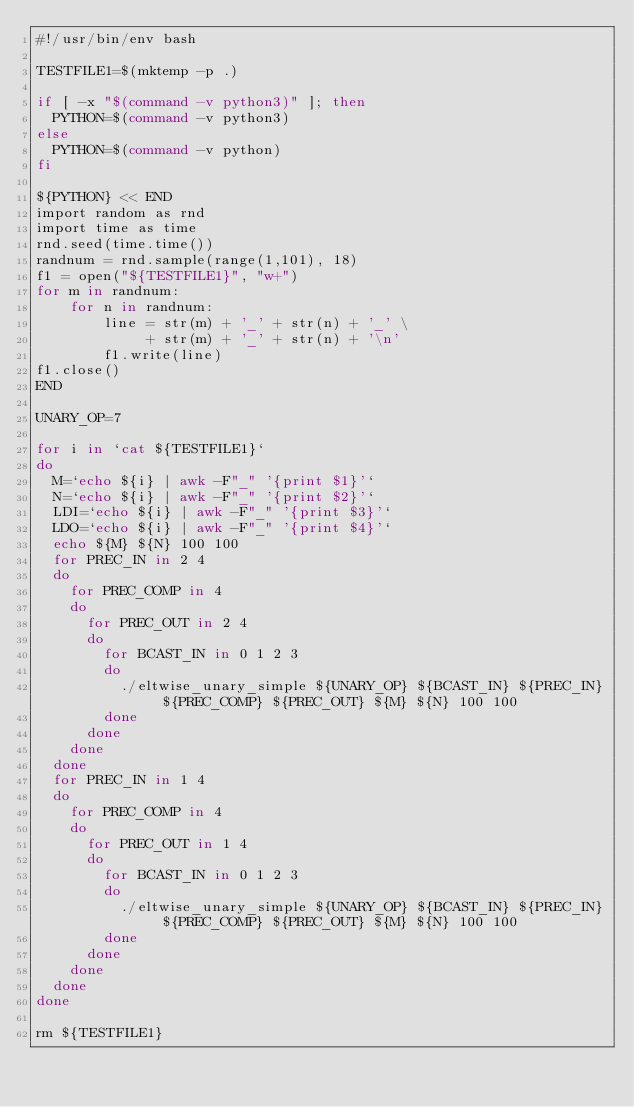Convert code to text. <code><loc_0><loc_0><loc_500><loc_500><_Bash_>#!/usr/bin/env bash

TESTFILE1=$(mktemp -p .)

if [ -x "$(command -v python3)" ]; then
  PYTHON=$(command -v python3)
else
  PYTHON=$(command -v python)
fi

${PYTHON} << END
import random as rnd
import time as time
rnd.seed(time.time())
randnum = rnd.sample(range(1,101), 18)
f1 = open("${TESTFILE1}", "w+")
for m in randnum:
    for n in randnum:
        line = str(m) + '_' + str(n) + '_' \
             + str(m) + '_' + str(n) + '\n'
        f1.write(line)
f1.close()
END

UNARY_OP=7

for i in `cat ${TESTFILE1}`
do
  M=`echo ${i} | awk -F"_" '{print $1}'`
  N=`echo ${i} | awk -F"_" '{print $2}'`
  LDI=`echo ${i} | awk -F"_" '{print $3}'`
  LDO=`echo ${i} | awk -F"_" '{print $4}'`
  echo ${M} ${N} 100 100
  for PREC_IN in 2 4
  do
    for PREC_COMP in 4
    do
      for PREC_OUT in 2 4
      do
        for BCAST_IN in 0 1 2 3
        do
          ./eltwise_unary_simple ${UNARY_OP} ${BCAST_IN} ${PREC_IN} ${PREC_COMP} ${PREC_OUT} ${M} ${N} 100 100
        done
      done
    done
  done
  for PREC_IN in 1 4
  do
    for PREC_COMP in 4
    do
      for PREC_OUT in 1 4
      do
        for BCAST_IN in 0 1 2 3
        do
          ./eltwise_unary_simple ${UNARY_OP} ${BCAST_IN} ${PREC_IN} ${PREC_COMP} ${PREC_OUT} ${M} ${N} 100 100
        done
      done
    done
  done
done

rm ${TESTFILE1}
</code> 